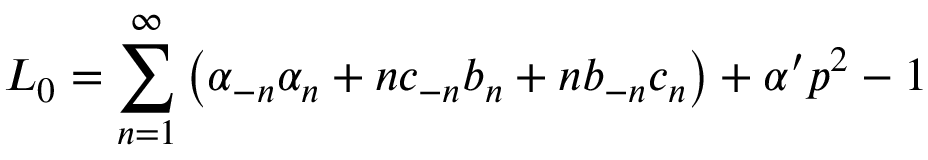<formula> <loc_0><loc_0><loc_500><loc_500>L _ { 0 } = \sum _ { n = 1 } ^ { \infty } \left ( \alpha _ { - n } \alpha _ { n } + n c _ { - n } b _ { n } + n b _ { - n } c _ { n } \right ) + \alpha ^ { \prime } p ^ { 2 } - 1</formula> 